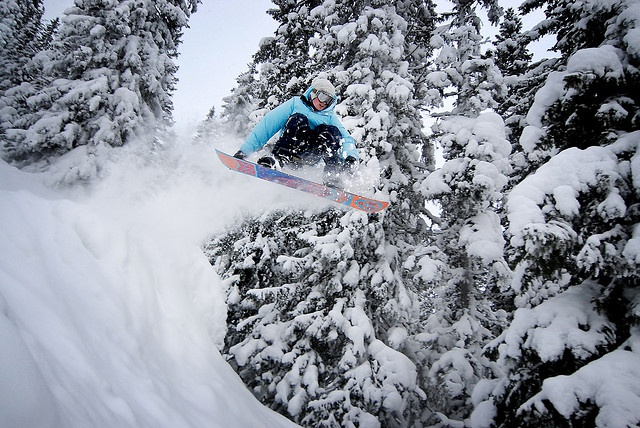Describe the objects in this image and their specific colors. I can see people in black, lightblue, darkgray, and gray tones and snowboard in black, darkgray, lightpink, gray, and salmon tones in this image. 